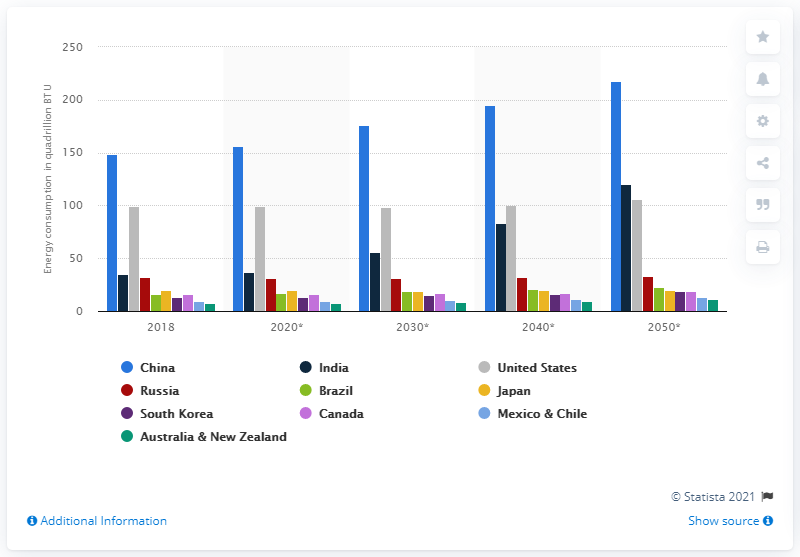Highlight a few significant elements in this photo. The projection of global energy consumption began in the year 2018. 